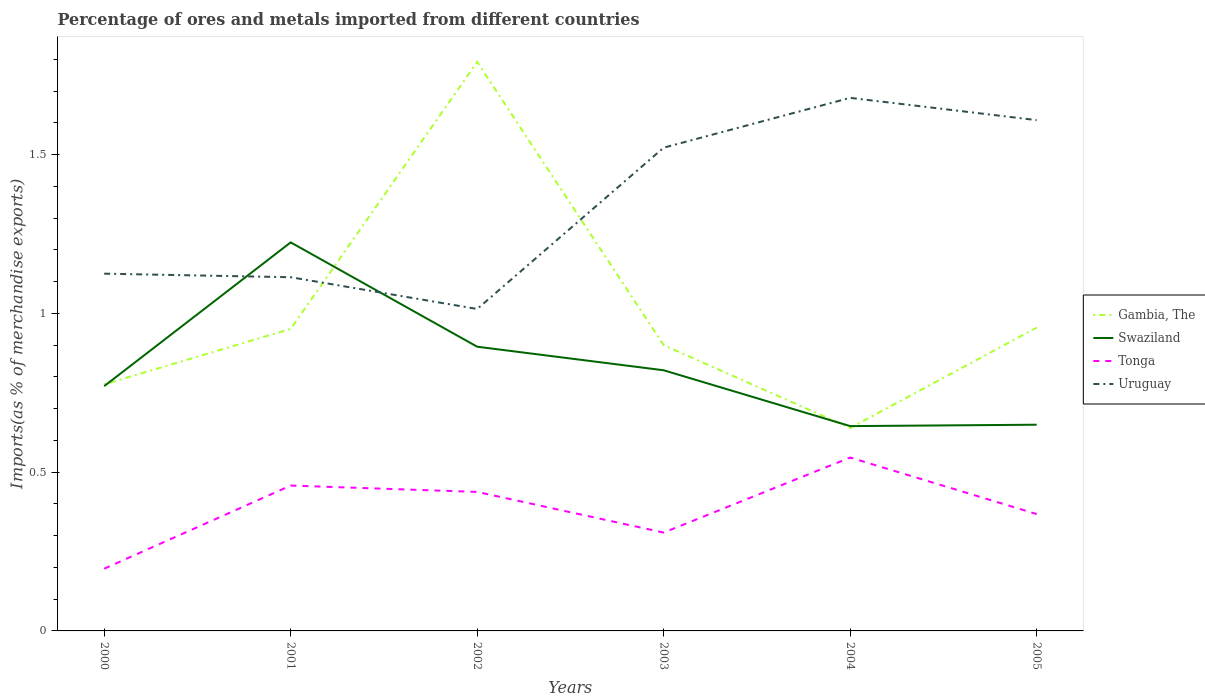Does the line corresponding to Uruguay intersect with the line corresponding to Gambia, The?
Make the answer very short. Yes. Across all years, what is the maximum percentage of imports to different countries in Gambia, The?
Your answer should be compact. 0.64. What is the total percentage of imports to different countries in Swaziland in the graph?
Provide a succinct answer. -0.12. What is the difference between the highest and the second highest percentage of imports to different countries in Swaziland?
Your response must be concise. 0.58. Is the percentage of imports to different countries in Swaziland strictly greater than the percentage of imports to different countries in Tonga over the years?
Make the answer very short. No. How many lines are there?
Ensure brevity in your answer.  4. What is the difference between two consecutive major ticks on the Y-axis?
Offer a terse response. 0.5. Where does the legend appear in the graph?
Offer a very short reply. Center right. How many legend labels are there?
Make the answer very short. 4. How are the legend labels stacked?
Offer a terse response. Vertical. What is the title of the graph?
Offer a very short reply. Percentage of ores and metals imported from different countries. Does "Brazil" appear as one of the legend labels in the graph?
Offer a very short reply. No. What is the label or title of the X-axis?
Your answer should be very brief. Years. What is the label or title of the Y-axis?
Offer a terse response. Imports(as % of merchandise exports). What is the Imports(as % of merchandise exports) in Gambia, The in 2000?
Offer a terse response. 0.78. What is the Imports(as % of merchandise exports) of Swaziland in 2000?
Ensure brevity in your answer.  0.77. What is the Imports(as % of merchandise exports) of Tonga in 2000?
Your response must be concise. 0.2. What is the Imports(as % of merchandise exports) of Uruguay in 2000?
Give a very brief answer. 1.13. What is the Imports(as % of merchandise exports) of Gambia, The in 2001?
Your answer should be compact. 0.95. What is the Imports(as % of merchandise exports) of Swaziland in 2001?
Keep it short and to the point. 1.22. What is the Imports(as % of merchandise exports) in Tonga in 2001?
Give a very brief answer. 0.46. What is the Imports(as % of merchandise exports) in Uruguay in 2001?
Your response must be concise. 1.11. What is the Imports(as % of merchandise exports) in Gambia, The in 2002?
Your response must be concise. 1.79. What is the Imports(as % of merchandise exports) of Swaziland in 2002?
Keep it short and to the point. 0.9. What is the Imports(as % of merchandise exports) in Tonga in 2002?
Your response must be concise. 0.44. What is the Imports(as % of merchandise exports) in Uruguay in 2002?
Make the answer very short. 1.01. What is the Imports(as % of merchandise exports) of Gambia, The in 2003?
Make the answer very short. 0.9. What is the Imports(as % of merchandise exports) of Swaziland in 2003?
Provide a succinct answer. 0.82. What is the Imports(as % of merchandise exports) in Tonga in 2003?
Your answer should be very brief. 0.31. What is the Imports(as % of merchandise exports) of Uruguay in 2003?
Offer a very short reply. 1.52. What is the Imports(as % of merchandise exports) of Gambia, The in 2004?
Provide a succinct answer. 0.64. What is the Imports(as % of merchandise exports) of Swaziland in 2004?
Your answer should be compact. 0.65. What is the Imports(as % of merchandise exports) of Tonga in 2004?
Provide a short and direct response. 0.55. What is the Imports(as % of merchandise exports) of Uruguay in 2004?
Ensure brevity in your answer.  1.68. What is the Imports(as % of merchandise exports) of Gambia, The in 2005?
Give a very brief answer. 0.96. What is the Imports(as % of merchandise exports) of Swaziland in 2005?
Provide a succinct answer. 0.65. What is the Imports(as % of merchandise exports) of Tonga in 2005?
Your answer should be compact. 0.37. What is the Imports(as % of merchandise exports) in Uruguay in 2005?
Ensure brevity in your answer.  1.61. Across all years, what is the maximum Imports(as % of merchandise exports) in Gambia, The?
Your answer should be compact. 1.79. Across all years, what is the maximum Imports(as % of merchandise exports) in Swaziland?
Your response must be concise. 1.22. Across all years, what is the maximum Imports(as % of merchandise exports) of Tonga?
Give a very brief answer. 0.55. Across all years, what is the maximum Imports(as % of merchandise exports) in Uruguay?
Your response must be concise. 1.68. Across all years, what is the minimum Imports(as % of merchandise exports) of Gambia, The?
Offer a very short reply. 0.64. Across all years, what is the minimum Imports(as % of merchandise exports) in Swaziland?
Your answer should be very brief. 0.65. Across all years, what is the minimum Imports(as % of merchandise exports) in Tonga?
Offer a very short reply. 0.2. Across all years, what is the minimum Imports(as % of merchandise exports) of Uruguay?
Offer a terse response. 1.01. What is the total Imports(as % of merchandise exports) in Gambia, The in the graph?
Ensure brevity in your answer.  6.01. What is the total Imports(as % of merchandise exports) of Swaziland in the graph?
Offer a very short reply. 5. What is the total Imports(as % of merchandise exports) of Tonga in the graph?
Make the answer very short. 2.32. What is the total Imports(as % of merchandise exports) of Uruguay in the graph?
Your answer should be very brief. 8.06. What is the difference between the Imports(as % of merchandise exports) of Gambia, The in 2000 and that in 2001?
Ensure brevity in your answer.  -0.17. What is the difference between the Imports(as % of merchandise exports) in Swaziland in 2000 and that in 2001?
Give a very brief answer. -0.45. What is the difference between the Imports(as % of merchandise exports) of Tonga in 2000 and that in 2001?
Your response must be concise. -0.26. What is the difference between the Imports(as % of merchandise exports) of Uruguay in 2000 and that in 2001?
Provide a succinct answer. 0.01. What is the difference between the Imports(as % of merchandise exports) in Gambia, The in 2000 and that in 2002?
Your response must be concise. -1.02. What is the difference between the Imports(as % of merchandise exports) of Swaziland in 2000 and that in 2002?
Your answer should be compact. -0.12. What is the difference between the Imports(as % of merchandise exports) in Tonga in 2000 and that in 2002?
Make the answer very short. -0.24. What is the difference between the Imports(as % of merchandise exports) in Uruguay in 2000 and that in 2002?
Make the answer very short. 0.11. What is the difference between the Imports(as % of merchandise exports) of Gambia, The in 2000 and that in 2003?
Make the answer very short. -0.12. What is the difference between the Imports(as % of merchandise exports) in Swaziland in 2000 and that in 2003?
Make the answer very short. -0.05. What is the difference between the Imports(as % of merchandise exports) of Tonga in 2000 and that in 2003?
Offer a very short reply. -0.11. What is the difference between the Imports(as % of merchandise exports) of Uruguay in 2000 and that in 2003?
Offer a very short reply. -0.4. What is the difference between the Imports(as % of merchandise exports) in Gambia, The in 2000 and that in 2004?
Your answer should be very brief. 0.14. What is the difference between the Imports(as % of merchandise exports) in Swaziland in 2000 and that in 2004?
Your response must be concise. 0.13. What is the difference between the Imports(as % of merchandise exports) of Tonga in 2000 and that in 2004?
Your answer should be compact. -0.35. What is the difference between the Imports(as % of merchandise exports) of Uruguay in 2000 and that in 2004?
Your answer should be compact. -0.55. What is the difference between the Imports(as % of merchandise exports) of Gambia, The in 2000 and that in 2005?
Provide a short and direct response. -0.18. What is the difference between the Imports(as % of merchandise exports) of Swaziland in 2000 and that in 2005?
Give a very brief answer. 0.12. What is the difference between the Imports(as % of merchandise exports) of Tonga in 2000 and that in 2005?
Provide a short and direct response. -0.17. What is the difference between the Imports(as % of merchandise exports) of Uruguay in 2000 and that in 2005?
Provide a succinct answer. -0.48. What is the difference between the Imports(as % of merchandise exports) of Gambia, The in 2001 and that in 2002?
Provide a short and direct response. -0.84. What is the difference between the Imports(as % of merchandise exports) in Swaziland in 2001 and that in 2002?
Ensure brevity in your answer.  0.33. What is the difference between the Imports(as % of merchandise exports) in Tonga in 2001 and that in 2002?
Your response must be concise. 0.02. What is the difference between the Imports(as % of merchandise exports) in Gambia, The in 2001 and that in 2003?
Make the answer very short. 0.05. What is the difference between the Imports(as % of merchandise exports) of Swaziland in 2001 and that in 2003?
Your response must be concise. 0.4. What is the difference between the Imports(as % of merchandise exports) in Tonga in 2001 and that in 2003?
Provide a short and direct response. 0.15. What is the difference between the Imports(as % of merchandise exports) in Uruguay in 2001 and that in 2003?
Keep it short and to the point. -0.41. What is the difference between the Imports(as % of merchandise exports) in Gambia, The in 2001 and that in 2004?
Make the answer very short. 0.31. What is the difference between the Imports(as % of merchandise exports) of Swaziland in 2001 and that in 2004?
Make the answer very short. 0.58. What is the difference between the Imports(as % of merchandise exports) in Tonga in 2001 and that in 2004?
Keep it short and to the point. -0.09. What is the difference between the Imports(as % of merchandise exports) in Uruguay in 2001 and that in 2004?
Offer a very short reply. -0.56. What is the difference between the Imports(as % of merchandise exports) in Gambia, The in 2001 and that in 2005?
Offer a very short reply. -0. What is the difference between the Imports(as % of merchandise exports) of Swaziland in 2001 and that in 2005?
Make the answer very short. 0.57. What is the difference between the Imports(as % of merchandise exports) of Tonga in 2001 and that in 2005?
Give a very brief answer. 0.09. What is the difference between the Imports(as % of merchandise exports) of Uruguay in 2001 and that in 2005?
Your answer should be very brief. -0.49. What is the difference between the Imports(as % of merchandise exports) of Gambia, The in 2002 and that in 2003?
Your answer should be compact. 0.89. What is the difference between the Imports(as % of merchandise exports) of Swaziland in 2002 and that in 2003?
Your answer should be very brief. 0.07. What is the difference between the Imports(as % of merchandise exports) in Tonga in 2002 and that in 2003?
Your answer should be very brief. 0.13. What is the difference between the Imports(as % of merchandise exports) of Uruguay in 2002 and that in 2003?
Ensure brevity in your answer.  -0.51. What is the difference between the Imports(as % of merchandise exports) of Gambia, The in 2002 and that in 2004?
Provide a succinct answer. 1.15. What is the difference between the Imports(as % of merchandise exports) in Tonga in 2002 and that in 2004?
Provide a succinct answer. -0.11. What is the difference between the Imports(as % of merchandise exports) of Uruguay in 2002 and that in 2004?
Your response must be concise. -0.66. What is the difference between the Imports(as % of merchandise exports) of Gambia, The in 2002 and that in 2005?
Offer a very short reply. 0.84. What is the difference between the Imports(as % of merchandise exports) in Swaziland in 2002 and that in 2005?
Ensure brevity in your answer.  0.25. What is the difference between the Imports(as % of merchandise exports) in Tonga in 2002 and that in 2005?
Offer a terse response. 0.07. What is the difference between the Imports(as % of merchandise exports) of Uruguay in 2002 and that in 2005?
Offer a very short reply. -0.59. What is the difference between the Imports(as % of merchandise exports) in Gambia, The in 2003 and that in 2004?
Ensure brevity in your answer.  0.26. What is the difference between the Imports(as % of merchandise exports) of Swaziland in 2003 and that in 2004?
Your response must be concise. 0.18. What is the difference between the Imports(as % of merchandise exports) of Tonga in 2003 and that in 2004?
Provide a succinct answer. -0.24. What is the difference between the Imports(as % of merchandise exports) in Uruguay in 2003 and that in 2004?
Provide a succinct answer. -0.16. What is the difference between the Imports(as % of merchandise exports) in Gambia, The in 2003 and that in 2005?
Make the answer very short. -0.06. What is the difference between the Imports(as % of merchandise exports) in Swaziland in 2003 and that in 2005?
Give a very brief answer. 0.17. What is the difference between the Imports(as % of merchandise exports) of Tonga in 2003 and that in 2005?
Your answer should be very brief. -0.06. What is the difference between the Imports(as % of merchandise exports) in Uruguay in 2003 and that in 2005?
Your response must be concise. -0.09. What is the difference between the Imports(as % of merchandise exports) of Gambia, The in 2004 and that in 2005?
Provide a succinct answer. -0.32. What is the difference between the Imports(as % of merchandise exports) of Swaziland in 2004 and that in 2005?
Your answer should be compact. -0. What is the difference between the Imports(as % of merchandise exports) in Tonga in 2004 and that in 2005?
Your answer should be compact. 0.18. What is the difference between the Imports(as % of merchandise exports) of Uruguay in 2004 and that in 2005?
Ensure brevity in your answer.  0.07. What is the difference between the Imports(as % of merchandise exports) in Gambia, The in 2000 and the Imports(as % of merchandise exports) in Swaziland in 2001?
Offer a very short reply. -0.45. What is the difference between the Imports(as % of merchandise exports) of Gambia, The in 2000 and the Imports(as % of merchandise exports) of Tonga in 2001?
Your response must be concise. 0.32. What is the difference between the Imports(as % of merchandise exports) in Gambia, The in 2000 and the Imports(as % of merchandise exports) in Uruguay in 2001?
Your answer should be very brief. -0.34. What is the difference between the Imports(as % of merchandise exports) of Swaziland in 2000 and the Imports(as % of merchandise exports) of Tonga in 2001?
Keep it short and to the point. 0.31. What is the difference between the Imports(as % of merchandise exports) of Swaziland in 2000 and the Imports(as % of merchandise exports) of Uruguay in 2001?
Give a very brief answer. -0.34. What is the difference between the Imports(as % of merchandise exports) of Tonga in 2000 and the Imports(as % of merchandise exports) of Uruguay in 2001?
Give a very brief answer. -0.92. What is the difference between the Imports(as % of merchandise exports) of Gambia, The in 2000 and the Imports(as % of merchandise exports) of Swaziland in 2002?
Provide a succinct answer. -0.12. What is the difference between the Imports(as % of merchandise exports) in Gambia, The in 2000 and the Imports(as % of merchandise exports) in Tonga in 2002?
Provide a short and direct response. 0.34. What is the difference between the Imports(as % of merchandise exports) of Gambia, The in 2000 and the Imports(as % of merchandise exports) of Uruguay in 2002?
Provide a short and direct response. -0.24. What is the difference between the Imports(as % of merchandise exports) of Swaziland in 2000 and the Imports(as % of merchandise exports) of Tonga in 2002?
Provide a short and direct response. 0.33. What is the difference between the Imports(as % of merchandise exports) in Swaziland in 2000 and the Imports(as % of merchandise exports) in Uruguay in 2002?
Ensure brevity in your answer.  -0.24. What is the difference between the Imports(as % of merchandise exports) in Tonga in 2000 and the Imports(as % of merchandise exports) in Uruguay in 2002?
Ensure brevity in your answer.  -0.82. What is the difference between the Imports(as % of merchandise exports) in Gambia, The in 2000 and the Imports(as % of merchandise exports) in Swaziland in 2003?
Your response must be concise. -0.04. What is the difference between the Imports(as % of merchandise exports) of Gambia, The in 2000 and the Imports(as % of merchandise exports) of Tonga in 2003?
Your answer should be very brief. 0.47. What is the difference between the Imports(as % of merchandise exports) in Gambia, The in 2000 and the Imports(as % of merchandise exports) in Uruguay in 2003?
Provide a short and direct response. -0.75. What is the difference between the Imports(as % of merchandise exports) in Swaziland in 2000 and the Imports(as % of merchandise exports) in Tonga in 2003?
Keep it short and to the point. 0.46. What is the difference between the Imports(as % of merchandise exports) of Swaziland in 2000 and the Imports(as % of merchandise exports) of Uruguay in 2003?
Ensure brevity in your answer.  -0.75. What is the difference between the Imports(as % of merchandise exports) of Tonga in 2000 and the Imports(as % of merchandise exports) of Uruguay in 2003?
Provide a short and direct response. -1.33. What is the difference between the Imports(as % of merchandise exports) of Gambia, The in 2000 and the Imports(as % of merchandise exports) of Swaziland in 2004?
Keep it short and to the point. 0.13. What is the difference between the Imports(as % of merchandise exports) in Gambia, The in 2000 and the Imports(as % of merchandise exports) in Tonga in 2004?
Make the answer very short. 0.23. What is the difference between the Imports(as % of merchandise exports) in Gambia, The in 2000 and the Imports(as % of merchandise exports) in Uruguay in 2004?
Provide a short and direct response. -0.9. What is the difference between the Imports(as % of merchandise exports) in Swaziland in 2000 and the Imports(as % of merchandise exports) in Tonga in 2004?
Provide a short and direct response. 0.22. What is the difference between the Imports(as % of merchandise exports) of Swaziland in 2000 and the Imports(as % of merchandise exports) of Uruguay in 2004?
Offer a terse response. -0.91. What is the difference between the Imports(as % of merchandise exports) in Tonga in 2000 and the Imports(as % of merchandise exports) in Uruguay in 2004?
Your answer should be very brief. -1.48. What is the difference between the Imports(as % of merchandise exports) in Gambia, The in 2000 and the Imports(as % of merchandise exports) in Swaziland in 2005?
Make the answer very short. 0.13. What is the difference between the Imports(as % of merchandise exports) in Gambia, The in 2000 and the Imports(as % of merchandise exports) in Tonga in 2005?
Your answer should be very brief. 0.41. What is the difference between the Imports(as % of merchandise exports) of Gambia, The in 2000 and the Imports(as % of merchandise exports) of Uruguay in 2005?
Offer a very short reply. -0.83. What is the difference between the Imports(as % of merchandise exports) in Swaziland in 2000 and the Imports(as % of merchandise exports) in Tonga in 2005?
Your answer should be very brief. 0.4. What is the difference between the Imports(as % of merchandise exports) of Swaziland in 2000 and the Imports(as % of merchandise exports) of Uruguay in 2005?
Keep it short and to the point. -0.84. What is the difference between the Imports(as % of merchandise exports) of Tonga in 2000 and the Imports(as % of merchandise exports) of Uruguay in 2005?
Provide a short and direct response. -1.41. What is the difference between the Imports(as % of merchandise exports) in Gambia, The in 2001 and the Imports(as % of merchandise exports) in Swaziland in 2002?
Offer a very short reply. 0.06. What is the difference between the Imports(as % of merchandise exports) in Gambia, The in 2001 and the Imports(as % of merchandise exports) in Tonga in 2002?
Offer a very short reply. 0.51. What is the difference between the Imports(as % of merchandise exports) in Gambia, The in 2001 and the Imports(as % of merchandise exports) in Uruguay in 2002?
Provide a short and direct response. -0.06. What is the difference between the Imports(as % of merchandise exports) of Swaziland in 2001 and the Imports(as % of merchandise exports) of Tonga in 2002?
Provide a short and direct response. 0.79. What is the difference between the Imports(as % of merchandise exports) in Swaziland in 2001 and the Imports(as % of merchandise exports) in Uruguay in 2002?
Offer a terse response. 0.21. What is the difference between the Imports(as % of merchandise exports) in Tonga in 2001 and the Imports(as % of merchandise exports) in Uruguay in 2002?
Your answer should be very brief. -0.56. What is the difference between the Imports(as % of merchandise exports) of Gambia, The in 2001 and the Imports(as % of merchandise exports) of Swaziland in 2003?
Make the answer very short. 0.13. What is the difference between the Imports(as % of merchandise exports) in Gambia, The in 2001 and the Imports(as % of merchandise exports) in Tonga in 2003?
Provide a short and direct response. 0.64. What is the difference between the Imports(as % of merchandise exports) in Gambia, The in 2001 and the Imports(as % of merchandise exports) in Uruguay in 2003?
Offer a very short reply. -0.57. What is the difference between the Imports(as % of merchandise exports) in Swaziland in 2001 and the Imports(as % of merchandise exports) in Tonga in 2003?
Your response must be concise. 0.91. What is the difference between the Imports(as % of merchandise exports) of Swaziland in 2001 and the Imports(as % of merchandise exports) of Uruguay in 2003?
Keep it short and to the point. -0.3. What is the difference between the Imports(as % of merchandise exports) in Tonga in 2001 and the Imports(as % of merchandise exports) in Uruguay in 2003?
Provide a short and direct response. -1.06. What is the difference between the Imports(as % of merchandise exports) of Gambia, The in 2001 and the Imports(as % of merchandise exports) of Swaziland in 2004?
Your answer should be compact. 0.31. What is the difference between the Imports(as % of merchandise exports) of Gambia, The in 2001 and the Imports(as % of merchandise exports) of Tonga in 2004?
Your answer should be compact. 0.41. What is the difference between the Imports(as % of merchandise exports) of Gambia, The in 2001 and the Imports(as % of merchandise exports) of Uruguay in 2004?
Your response must be concise. -0.73. What is the difference between the Imports(as % of merchandise exports) of Swaziland in 2001 and the Imports(as % of merchandise exports) of Tonga in 2004?
Give a very brief answer. 0.68. What is the difference between the Imports(as % of merchandise exports) of Swaziland in 2001 and the Imports(as % of merchandise exports) of Uruguay in 2004?
Ensure brevity in your answer.  -0.46. What is the difference between the Imports(as % of merchandise exports) in Tonga in 2001 and the Imports(as % of merchandise exports) in Uruguay in 2004?
Keep it short and to the point. -1.22. What is the difference between the Imports(as % of merchandise exports) of Gambia, The in 2001 and the Imports(as % of merchandise exports) of Swaziland in 2005?
Provide a short and direct response. 0.3. What is the difference between the Imports(as % of merchandise exports) in Gambia, The in 2001 and the Imports(as % of merchandise exports) in Tonga in 2005?
Provide a short and direct response. 0.58. What is the difference between the Imports(as % of merchandise exports) of Gambia, The in 2001 and the Imports(as % of merchandise exports) of Uruguay in 2005?
Provide a short and direct response. -0.66. What is the difference between the Imports(as % of merchandise exports) of Swaziland in 2001 and the Imports(as % of merchandise exports) of Tonga in 2005?
Offer a very short reply. 0.86. What is the difference between the Imports(as % of merchandise exports) of Swaziland in 2001 and the Imports(as % of merchandise exports) of Uruguay in 2005?
Offer a very short reply. -0.39. What is the difference between the Imports(as % of merchandise exports) in Tonga in 2001 and the Imports(as % of merchandise exports) in Uruguay in 2005?
Keep it short and to the point. -1.15. What is the difference between the Imports(as % of merchandise exports) of Gambia, The in 2002 and the Imports(as % of merchandise exports) of Swaziland in 2003?
Ensure brevity in your answer.  0.97. What is the difference between the Imports(as % of merchandise exports) of Gambia, The in 2002 and the Imports(as % of merchandise exports) of Tonga in 2003?
Provide a short and direct response. 1.48. What is the difference between the Imports(as % of merchandise exports) in Gambia, The in 2002 and the Imports(as % of merchandise exports) in Uruguay in 2003?
Your answer should be compact. 0.27. What is the difference between the Imports(as % of merchandise exports) in Swaziland in 2002 and the Imports(as % of merchandise exports) in Tonga in 2003?
Offer a terse response. 0.59. What is the difference between the Imports(as % of merchandise exports) of Swaziland in 2002 and the Imports(as % of merchandise exports) of Uruguay in 2003?
Offer a very short reply. -0.63. What is the difference between the Imports(as % of merchandise exports) in Tonga in 2002 and the Imports(as % of merchandise exports) in Uruguay in 2003?
Make the answer very short. -1.08. What is the difference between the Imports(as % of merchandise exports) in Gambia, The in 2002 and the Imports(as % of merchandise exports) in Swaziland in 2004?
Your answer should be very brief. 1.15. What is the difference between the Imports(as % of merchandise exports) in Gambia, The in 2002 and the Imports(as % of merchandise exports) in Tonga in 2004?
Make the answer very short. 1.25. What is the difference between the Imports(as % of merchandise exports) of Gambia, The in 2002 and the Imports(as % of merchandise exports) of Uruguay in 2004?
Your answer should be very brief. 0.11. What is the difference between the Imports(as % of merchandise exports) of Swaziland in 2002 and the Imports(as % of merchandise exports) of Tonga in 2004?
Your response must be concise. 0.35. What is the difference between the Imports(as % of merchandise exports) of Swaziland in 2002 and the Imports(as % of merchandise exports) of Uruguay in 2004?
Your response must be concise. -0.78. What is the difference between the Imports(as % of merchandise exports) in Tonga in 2002 and the Imports(as % of merchandise exports) in Uruguay in 2004?
Make the answer very short. -1.24. What is the difference between the Imports(as % of merchandise exports) in Gambia, The in 2002 and the Imports(as % of merchandise exports) in Swaziland in 2005?
Ensure brevity in your answer.  1.14. What is the difference between the Imports(as % of merchandise exports) of Gambia, The in 2002 and the Imports(as % of merchandise exports) of Tonga in 2005?
Give a very brief answer. 1.42. What is the difference between the Imports(as % of merchandise exports) in Gambia, The in 2002 and the Imports(as % of merchandise exports) in Uruguay in 2005?
Offer a very short reply. 0.18. What is the difference between the Imports(as % of merchandise exports) of Swaziland in 2002 and the Imports(as % of merchandise exports) of Tonga in 2005?
Your answer should be compact. 0.53. What is the difference between the Imports(as % of merchandise exports) in Swaziland in 2002 and the Imports(as % of merchandise exports) in Uruguay in 2005?
Your answer should be very brief. -0.71. What is the difference between the Imports(as % of merchandise exports) of Tonga in 2002 and the Imports(as % of merchandise exports) of Uruguay in 2005?
Ensure brevity in your answer.  -1.17. What is the difference between the Imports(as % of merchandise exports) of Gambia, The in 2003 and the Imports(as % of merchandise exports) of Swaziland in 2004?
Offer a terse response. 0.26. What is the difference between the Imports(as % of merchandise exports) of Gambia, The in 2003 and the Imports(as % of merchandise exports) of Tonga in 2004?
Your answer should be compact. 0.35. What is the difference between the Imports(as % of merchandise exports) of Gambia, The in 2003 and the Imports(as % of merchandise exports) of Uruguay in 2004?
Your answer should be compact. -0.78. What is the difference between the Imports(as % of merchandise exports) in Swaziland in 2003 and the Imports(as % of merchandise exports) in Tonga in 2004?
Your response must be concise. 0.27. What is the difference between the Imports(as % of merchandise exports) of Swaziland in 2003 and the Imports(as % of merchandise exports) of Uruguay in 2004?
Your answer should be compact. -0.86. What is the difference between the Imports(as % of merchandise exports) of Tonga in 2003 and the Imports(as % of merchandise exports) of Uruguay in 2004?
Offer a very short reply. -1.37. What is the difference between the Imports(as % of merchandise exports) in Gambia, The in 2003 and the Imports(as % of merchandise exports) in Swaziland in 2005?
Make the answer very short. 0.25. What is the difference between the Imports(as % of merchandise exports) of Gambia, The in 2003 and the Imports(as % of merchandise exports) of Tonga in 2005?
Give a very brief answer. 0.53. What is the difference between the Imports(as % of merchandise exports) in Gambia, The in 2003 and the Imports(as % of merchandise exports) in Uruguay in 2005?
Your answer should be compact. -0.71. What is the difference between the Imports(as % of merchandise exports) in Swaziland in 2003 and the Imports(as % of merchandise exports) in Tonga in 2005?
Provide a short and direct response. 0.45. What is the difference between the Imports(as % of merchandise exports) of Swaziland in 2003 and the Imports(as % of merchandise exports) of Uruguay in 2005?
Offer a terse response. -0.79. What is the difference between the Imports(as % of merchandise exports) in Tonga in 2003 and the Imports(as % of merchandise exports) in Uruguay in 2005?
Provide a succinct answer. -1.3. What is the difference between the Imports(as % of merchandise exports) in Gambia, The in 2004 and the Imports(as % of merchandise exports) in Swaziland in 2005?
Keep it short and to the point. -0.01. What is the difference between the Imports(as % of merchandise exports) of Gambia, The in 2004 and the Imports(as % of merchandise exports) of Tonga in 2005?
Ensure brevity in your answer.  0.27. What is the difference between the Imports(as % of merchandise exports) in Gambia, The in 2004 and the Imports(as % of merchandise exports) in Uruguay in 2005?
Ensure brevity in your answer.  -0.97. What is the difference between the Imports(as % of merchandise exports) in Swaziland in 2004 and the Imports(as % of merchandise exports) in Tonga in 2005?
Your answer should be compact. 0.28. What is the difference between the Imports(as % of merchandise exports) of Swaziland in 2004 and the Imports(as % of merchandise exports) of Uruguay in 2005?
Your answer should be compact. -0.96. What is the difference between the Imports(as % of merchandise exports) in Tonga in 2004 and the Imports(as % of merchandise exports) in Uruguay in 2005?
Your answer should be very brief. -1.06. What is the average Imports(as % of merchandise exports) in Swaziland per year?
Give a very brief answer. 0.83. What is the average Imports(as % of merchandise exports) of Tonga per year?
Offer a terse response. 0.39. What is the average Imports(as % of merchandise exports) of Uruguay per year?
Your answer should be very brief. 1.34. In the year 2000, what is the difference between the Imports(as % of merchandise exports) in Gambia, The and Imports(as % of merchandise exports) in Swaziland?
Give a very brief answer. 0.01. In the year 2000, what is the difference between the Imports(as % of merchandise exports) of Gambia, The and Imports(as % of merchandise exports) of Tonga?
Your answer should be very brief. 0.58. In the year 2000, what is the difference between the Imports(as % of merchandise exports) in Gambia, The and Imports(as % of merchandise exports) in Uruguay?
Your answer should be compact. -0.35. In the year 2000, what is the difference between the Imports(as % of merchandise exports) in Swaziland and Imports(as % of merchandise exports) in Tonga?
Offer a terse response. 0.57. In the year 2000, what is the difference between the Imports(as % of merchandise exports) in Swaziland and Imports(as % of merchandise exports) in Uruguay?
Your response must be concise. -0.35. In the year 2000, what is the difference between the Imports(as % of merchandise exports) in Tonga and Imports(as % of merchandise exports) in Uruguay?
Provide a succinct answer. -0.93. In the year 2001, what is the difference between the Imports(as % of merchandise exports) in Gambia, The and Imports(as % of merchandise exports) in Swaziland?
Ensure brevity in your answer.  -0.27. In the year 2001, what is the difference between the Imports(as % of merchandise exports) of Gambia, The and Imports(as % of merchandise exports) of Tonga?
Provide a succinct answer. 0.49. In the year 2001, what is the difference between the Imports(as % of merchandise exports) of Gambia, The and Imports(as % of merchandise exports) of Uruguay?
Ensure brevity in your answer.  -0.16. In the year 2001, what is the difference between the Imports(as % of merchandise exports) in Swaziland and Imports(as % of merchandise exports) in Tonga?
Give a very brief answer. 0.77. In the year 2001, what is the difference between the Imports(as % of merchandise exports) in Swaziland and Imports(as % of merchandise exports) in Uruguay?
Provide a succinct answer. 0.11. In the year 2001, what is the difference between the Imports(as % of merchandise exports) in Tonga and Imports(as % of merchandise exports) in Uruguay?
Provide a short and direct response. -0.66. In the year 2002, what is the difference between the Imports(as % of merchandise exports) in Gambia, The and Imports(as % of merchandise exports) in Swaziland?
Give a very brief answer. 0.9. In the year 2002, what is the difference between the Imports(as % of merchandise exports) in Gambia, The and Imports(as % of merchandise exports) in Tonga?
Keep it short and to the point. 1.35. In the year 2002, what is the difference between the Imports(as % of merchandise exports) of Gambia, The and Imports(as % of merchandise exports) of Uruguay?
Provide a short and direct response. 0.78. In the year 2002, what is the difference between the Imports(as % of merchandise exports) of Swaziland and Imports(as % of merchandise exports) of Tonga?
Your answer should be very brief. 0.46. In the year 2002, what is the difference between the Imports(as % of merchandise exports) of Swaziland and Imports(as % of merchandise exports) of Uruguay?
Your response must be concise. -0.12. In the year 2002, what is the difference between the Imports(as % of merchandise exports) in Tonga and Imports(as % of merchandise exports) in Uruguay?
Give a very brief answer. -0.58. In the year 2003, what is the difference between the Imports(as % of merchandise exports) of Gambia, The and Imports(as % of merchandise exports) of Swaziland?
Your response must be concise. 0.08. In the year 2003, what is the difference between the Imports(as % of merchandise exports) of Gambia, The and Imports(as % of merchandise exports) of Tonga?
Keep it short and to the point. 0.59. In the year 2003, what is the difference between the Imports(as % of merchandise exports) of Gambia, The and Imports(as % of merchandise exports) of Uruguay?
Offer a terse response. -0.62. In the year 2003, what is the difference between the Imports(as % of merchandise exports) of Swaziland and Imports(as % of merchandise exports) of Tonga?
Ensure brevity in your answer.  0.51. In the year 2003, what is the difference between the Imports(as % of merchandise exports) of Swaziland and Imports(as % of merchandise exports) of Uruguay?
Make the answer very short. -0.7. In the year 2003, what is the difference between the Imports(as % of merchandise exports) of Tonga and Imports(as % of merchandise exports) of Uruguay?
Your response must be concise. -1.21. In the year 2004, what is the difference between the Imports(as % of merchandise exports) of Gambia, The and Imports(as % of merchandise exports) of Swaziland?
Your answer should be compact. -0.01. In the year 2004, what is the difference between the Imports(as % of merchandise exports) of Gambia, The and Imports(as % of merchandise exports) of Tonga?
Your answer should be compact. 0.09. In the year 2004, what is the difference between the Imports(as % of merchandise exports) in Gambia, The and Imports(as % of merchandise exports) in Uruguay?
Provide a succinct answer. -1.04. In the year 2004, what is the difference between the Imports(as % of merchandise exports) of Swaziland and Imports(as % of merchandise exports) of Tonga?
Ensure brevity in your answer.  0.1. In the year 2004, what is the difference between the Imports(as % of merchandise exports) in Swaziland and Imports(as % of merchandise exports) in Uruguay?
Your answer should be very brief. -1.03. In the year 2004, what is the difference between the Imports(as % of merchandise exports) in Tonga and Imports(as % of merchandise exports) in Uruguay?
Provide a succinct answer. -1.13. In the year 2005, what is the difference between the Imports(as % of merchandise exports) of Gambia, The and Imports(as % of merchandise exports) of Swaziland?
Your answer should be compact. 0.31. In the year 2005, what is the difference between the Imports(as % of merchandise exports) of Gambia, The and Imports(as % of merchandise exports) of Tonga?
Offer a very short reply. 0.59. In the year 2005, what is the difference between the Imports(as % of merchandise exports) of Gambia, The and Imports(as % of merchandise exports) of Uruguay?
Your answer should be very brief. -0.65. In the year 2005, what is the difference between the Imports(as % of merchandise exports) of Swaziland and Imports(as % of merchandise exports) of Tonga?
Give a very brief answer. 0.28. In the year 2005, what is the difference between the Imports(as % of merchandise exports) in Swaziland and Imports(as % of merchandise exports) in Uruguay?
Your answer should be very brief. -0.96. In the year 2005, what is the difference between the Imports(as % of merchandise exports) in Tonga and Imports(as % of merchandise exports) in Uruguay?
Offer a terse response. -1.24. What is the ratio of the Imports(as % of merchandise exports) in Gambia, The in 2000 to that in 2001?
Provide a short and direct response. 0.82. What is the ratio of the Imports(as % of merchandise exports) in Swaziland in 2000 to that in 2001?
Make the answer very short. 0.63. What is the ratio of the Imports(as % of merchandise exports) in Tonga in 2000 to that in 2001?
Your answer should be very brief. 0.43. What is the ratio of the Imports(as % of merchandise exports) in Gambia, The in 2000 to that in 2002?
Give a very brief answer. 0.43. What is the ratio of the Imports(as % of merchandise exports) in Swaziland in 2000 to that in 2002?
Your answer should be very brief. 0.86. What is the ratio of the Imports(as % of merchandise exports) in Tonga in 2000 to that in 2002?
Your answer should be very brief. 0.45. What is the ratio of the Imports(as % of merchandise exports) in Uruguay in 2000 to that in 2002?
Make the answer very short. 1.11. What is the ratio of the Imports(as % of merchandise exports) in Gambia, The in 2000 to that in 2003?
Offer a terse response. 0.86. What is the ratio of the Imports(as % of merchandise exports) of Swaziland in 2000 to that in 2003?
Provide a short and direct response. 0.94. What is the ratio of the Imports(as % of merchandise exports) in Tonga in 2000 to that in 2003?
Your response must be concise. 0.63. What is the ratio of the Imports(as % of merchandise exports) of Uruguay in 2000 to that in 2003?
Your response must be concise. 0.74. What is the ratio of the Imports(as % of merchandise exports) in Gambia, The in 2000 to that in 2004?
Your answer should be compact. 1.21. What is the ratio of the Imports(as % of merchandise exports) of Swaziland in 2000 to that in 2004?
Ensure brevity in your answer.  1.2. What is the ratio of the Imports(as % of merchandise exports) in Tonga in 2000 to that in 2004?
Provide a succinct answer. 0.36. What is the ratio of the Imports(as % of merchandise exports) of Uruguay in 2000 to that in 2004?
Your response must be concise. 0.67. What is the ratio of the Imports(as % of merchandise exports) in Gambia, The in 2000 to that in 2005?
Your answer should be very brief. 0.81. What is the ratio of the Imports(as % of merchandise exports) in Swaziland in 2000 to that in 2005?
Your answer should be compact. 1.19. What is the ratio of the Imports(as % of merchandise exports) of Tonga in 2000 to that in 2005?
Offer a very short reply. 0.53. What is the ratio of the Imports(as % of merchandise exports) of Uruguay in 2000 to that in 2005?
Keep it short and to the point. 0.7. What is the ratio of the Imports(as % of merchandise exports) of Gambia, The in 2001 to that in 2002?
Keep it short and to the point. 0.53. What is the ratio of the Imports(as % of merchandise exports) of Swaziland in 2001 to that in 2002?
Your answer should be compact. 1.37. What is the ratio of the Imports(as % of merchandise exports) in Tonga in 2001 to that in 2002?
Offer a terse response. 1.05. What is the ratio of the Imports(as % of merchandise exports) in Uruguay in 2001 to that in 2002?
Offer a very short reply. 1.1. What is the ratio of the Imports(as % of merchandise exports) in Gambia, The in 2001 to that in 2003?
Provide a short and direct response. 1.06. What is the ratio of the Imports(as % of merchandise exports) in Swaziland in 2001 to that in 2003?
Give a very brief answer. 1.49. What is the ratio of the Imports(as % of merchandise exports) in Tonga in 2001 to that in 2003?
Offer a very short reply. 1.48. What is the ratio of the Imports(as % of merchandise exports) of Uruguay in 2001 to that in 2003?
Offer a very short reply. 0.73. What is the ratio of the Imports(as % of merchandise exports) of Gambia, The in 2001 to that in 2004?
Your response must be concise. 1.49. What is the ratio of the Imports(as % of merchandise exports) in Swaziland in 2001 to that in 2004?
Your answer should be very brief. 1.9. What is the ratio of the Imports(as % of merchandise exports) of Tonga in 2001 to that in 2004?
Your answer should be very brief. 0.84. What is the ratio of the Imports(as % of merchandise exports) of Uruguay in 2001 to that in 2004?
Offer a very short reply. 0.66. What is the ratio of the Imports(as % of merchandise exports) in Swaziland in 2001 to that in 2005?
Offer a terse response. 1.88. What is the ratio of the Imports(as % of merchandise exports) of Tonga in 2001 to that in 2005?
Make the answer very short. 1.24. What is the ratio of the Imports(as % of merchandise exports) of Uruguay in 2001 to that in 2005?
Your response must be concise. 0.69. What is the ratio of the Imports(as % of merchandise exports) in Gambia, The in 2002 to that in 2003?
Ensure brevity in your answer.  1.99. What is the ratio of the Imports(as % of merchandise exports) of Swaziland in 2002 to that in 2003?
Provide a succinct answer. 1.09. What is the ratio of the Imports(as % of merchandise exports) of Tonga in 2002 to that in 2003?
Offer a terse response. 1.41. What is the ratio of the Imports(as % of merchandise exports) of Uruguay in 2002 to that in 2003?
Keep it short and to the point. 0.67. What is the ratio of the Imports(as % of merchandise exports) in Gambia, The in 2002 to that in 2004?
Keep it short and to the point. 2.8. What is the ratio of the Imports(as % of merchandise exports) of Swaziland in 2002 to that in 2004?
Your answer should be compact. 1.39. What is the ratio of the Imports(as % of merchandise exports) in Tonga in 2002 to that in 2004?
Your answer should be compact. 0.8. What is the ratio of the Imports(as % of merchandise exports) in Uruguay in 2002 to that in 2004?
Offer a very short reply. 0.6. What is the ratio of the Imports(as % of merchandise exports) of Gambia, The in 2002 to that in 2005?
Your response must be concise. 1.88. What is the ratio of the Imports(as % of merchandise exports) of Swaziland in 2002 to that in 2005?
Give a very brief answer. 1.38. What is the ratio of the Imports(as % of merchandise exports) in Tonga in 2002 to that in 2005?
Make the answer very short. 1.19. What is the ratio of the Imports(as % of merchandise exports) in Uruguay in 2002 to that in 2005?
Provide a succinct answer. 0.63. What is the ratio of the Imports(as % of merchandise exports) in Gambia, The in 2003 to that in 2004?
Your answer should be compact. 1.41. What is the ratio of the Imports(as % of merchandise exports) in Swaziland in 2003 to that in 2004?
Give a very brief answer. 1.27. What is the ratio of the Imports(as % of merchandise exports) in Tonga in 2003 to that in 2004?
Offer a very short reply. 0.57. What is the ratio of the Imports(as % of merchandise exports) of Uruguay in 2003 to that in 2004?
Offer a very short reply. 0.91. What is the ratio of the Imports(as % of merchandise exports) in Gambia, The in 2003 to that in 2005?
Give a very brief answer. 0.94. What is the ratio of the Imports(as % of merchandise exports) of Swaziland in 2003 to that in 2005?
Keep it short and to the point. 1.26. What is the ratio of the Imports(as % of merchandise exports) in Tonga in 2003 to that in 2005?
Offer a very short reply. 0.84. What is the ratio of the Imports(as % of merchandise exports) in Uruguay in 2003 to that in 2005?
Your answer should be very brief. 0.95. What is the ratio of the Imports(as % of merchandise exports) in Gambia, The in 2004 to that in 2005?
Give a very brief answer. 0.67. What is the ratio of the Imports(as % of merchandise exports) of Swaziland in 2004 to that in 2005?
Provide a succinct answer. 0.99. What is the ratio of the Imports(as % of merchandise exports) of Tonga in 2004 to that in 2005?
Your response must be concise. 1.48. What is the ratio of the Imports(as % of merchandise exports) of Uruguay in 2004 to that in 2005?
Offer a very short reply. 1.04. What is the difference between the highest and the second highest Imports(as % of merchandise exports) in Gambia, The?
Your answer should be very brief. 0.84. What is the difference between the highest and the second highest Imports(as % of merchandise exports) in Swaziland?
Provide a succinct answer. 0.33. What is the difference between the highest and the second highest Imports(as % of merchandise exports) in Tonga?
Provide a short and direct response. 0.09. What is the difference between the highest and the second highest Imports(as % of merchandise exports) of Uruguay?
Offer a very short reply. 0.07. What is the difference between the highest and the lowest Imports(as % of merchandise exports) of Gambia, The?
Offer a terse response. 1.15. What is the difference between the highest and the lowest Imports(as % of merchandise exports) in Swaziland?
Give a very brief answer. 0.58. What is the difference between the highest and the lowest Imports(as % of merchandise exports) in Tonga?
Provide a succinct answer. 0.35. What is the difference between the highest and the lowest Imports(as % of merchandise exports) of Uruguay?
Offer a very short reply. 0.66. 